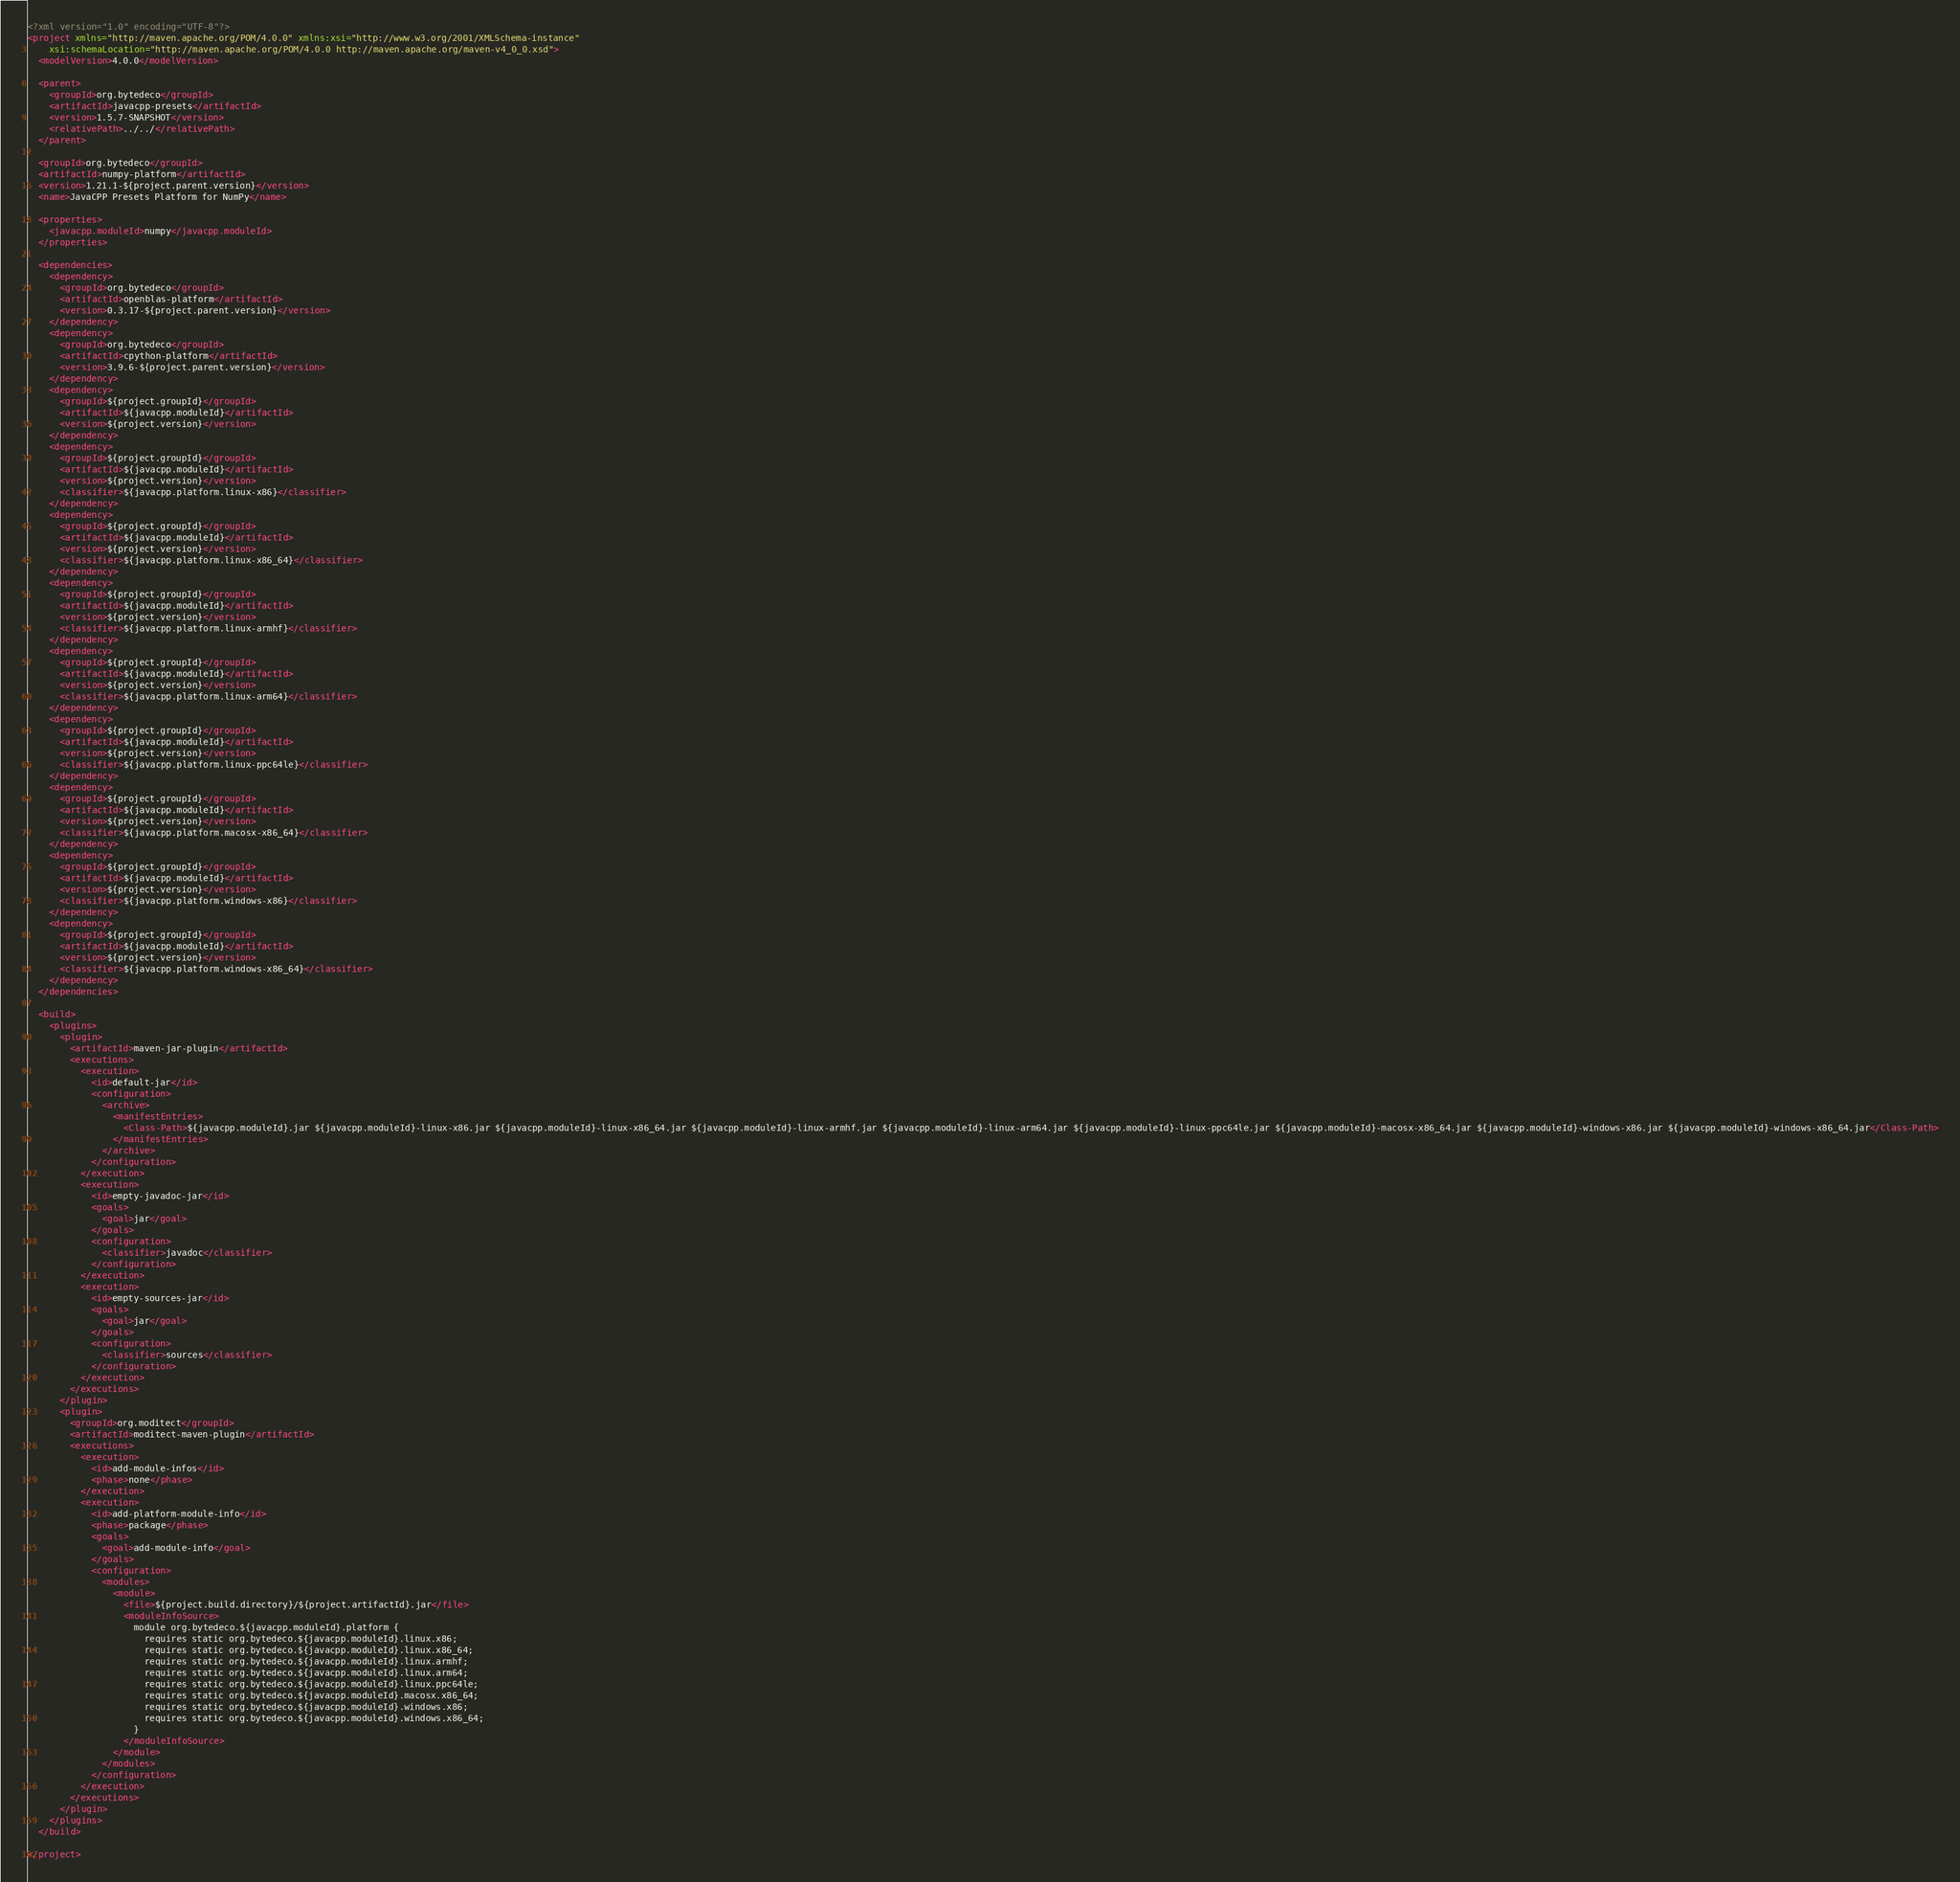Convert code to text. <code><loc_0><loc_0><loc_500><loc_500><_XML_><?xml version="1.0" encoding="UTF-8"?>
<project xmlns="http://maven.apache.org/POM/4.0.0" xmlns:xsi="http://www.w3.org/2001/XMLSchema-instance"
    xsi:schemaLocation="http://maven.apache.org/POM/4.0.0 http://maven.apache.org/maven-v4_0_0.xsd">
  <modelVersion>4.0.0</modelVersion>

  <parent>
    <groupId>org.bytedeco</groupId>
    <artifactId>javacpp-presets</artifactId>
    <version>1.5.7-SNAPSHOT</version>
    <relativePath>../../</relativePath>
  </parent>

  <groupId>org.bytedeco</groupId>
  <artifactId>numpy-platform</artifactId>
  <version>1.21.1-${project.parent.version}</version>
  <name>JavaCPP Presets Platform for NumPy</name>

  <properties>
    <javacpp.moduleId>numpy</javacpp.moduleId>
  </properties>

  <dependencies>
    <dependency>
      <groupId>org.bytedeco</groupId>
      <artifactId>openblas-platform</artifactId>
      <version>0.3.17-${project.parent.version}</version>
    </dependency>
    <dependency>
      <groupId>org.bytedeco</groupId>
      <artifactId>cpython-platform</artifactId>
      <version>3.9.6-${project.parent.version}</version>
    </dependency>
    <dependency>
      <groupId>${project.groupId}</groupId>
      <artifactId>${javacpp.moduleId}</artifactId>
      <version>${project.version}</version>
    </dependency>
    <dependency>
      <groupId>${project.groupId}</groupId>
      <artifactId>${javacpp.moduleId}</artifactId>
      <version>${project.version}</version>
      <classifier>${javacpp.platform.linux-x86}</classifier>
    </dependency>
    <dependency>
      <groupId>${project.groupId}</groupId>
      <artifactId>${javacpp.moduleId}</artifactId>
      <version>${project.version}</version>
      <classifier>${javacpp.platform.linux-x86_64}</classifier>
    </dependency>
    <dependency>
      <groupId>${project.groupId}</groupId>
      <artifactId>${javacpp.moduleId}</artifactId>
      <version>${project.version}</version>
      <classifier>${javacpp.platform.linux-armhf}</classifier>
    </dependency>
    <dependency>
      <groupId>${project.groupId}</groupId>
      <artifactId>${javacpp.moduleId}</artifactId>
      <version>${project.version}</version>
      <classifier>${javacpp.platform.linux-arm64}</classifier>
    </dependency>
    <dependency>
      <groupId>${project.groupId}</groupId>
      <artifactId>${javacpp.moduleId}</artifactId>
      <version>${project.version}</version>
      <classifier>${javacpp.platform.linux-ppc64le}</classifier>
    </dependency>
    <dependency>
      <groupId>${project.groupId}</groupId>
      <artifactId>${javacpp.moduleId}</artifactId>
      <version>${project.version}</version>
      <classifier>${javacpp.platform.macosx-x86_64}</classifier>
    </dependency>
    <dependency>
      <groupId>${project.groupId}</groupId>
      <artifactId>${javacpp.moduleId}</artifactId>
      <version>${project.version}</version>
      <classifier>${javacpp.platform.windows-x86}</classifier>
    </dependency>
    <dependency>
      <groupId>${project.groupId}</groupId>
      <artifactId>${javacpp.moduleId}</artifactId>
      <version>${project.version}</version>
      <classifier>${javacpp.platform.windows-x86_64}</classifier>
    </dependency>
  </dependencies>

  <build>
    <plugins>
      <plugin>
        <artifactId>maven-jar-plugin</artifactId>
        <executions>
          <execution>
            <id>default-jar</id>
            <configuration>
              <archive>
                <manifestEntries>
                  <Class-Path>${javacpp.moduleId}.jar ${javacpp.moduleId}-linux-x86.jar ${javacpp.moduleId}-linux-x86_64.jar ${javacpp.moduleId}-linux-armhf.jar ${javacpp.moduleId}-linux-arm64.jar ${javacpp.moduleId}-linux-ppc64le.jar ${javacpp.moduleId}-macosx-x86_64.jar ${javacpp.moduleId}-windows-x86.jar ${javacpp.moduleId}-windows-x86_64.jar</Class-Path>
                </manifestEntries>
              </archive>
            </configuration>
          </execution>
          <execution>
            <id>empty-javadoc-jar</id>
            <goals>
              <goal>jar</goal>
            </goals>
            <configuration>
              <classifier>javadoc</classifier>
            </configuration>
          </execution>
          <execution>
            <id>empty-sources-jar</id>
            <goals>
              <goal>jar</goal>
            </goals>
            <configuration>
              <classifier>sources</classifier>
            </configuration>
          </execution>
        </executions>
      </plugin>
      <plugin>
        <groupId>org.moditect</groupId>
        <artifactId>moditect-maven-plugin</artifactId>
        <executions>
          <execution>
            <id>add-module-infos</id>
            <phase>none</phase>
          </execution>
          <execution>
            <id>add-platform-module-info</id>
            <phase>package</phase>
            <goals>
              <goal>add-module-info</goal>
            </goals>
            <configuration>
              <modules>
                <module>
                  <file>${project.build.directory}/${project.artifactId}.jar</file>
                  <moduleInfoSource>
                    module org.bytedeco.${javacpp.moduleId}.platform {
                      requires static org.bytedeco.${javacpp.moduleId}.linux.x86;
                      requires static org.bytedeco.${javacpp.moduleId}.linux.x86_64;
                      requires static org.bytedeco.${javacpp.moduleId}.linux.armhf;
                      requires static org.bytedeco.${javacpp.moduleId}.linux.arm64;
                      requires static org.bytedeco.${javacpp.moduleId}.linux.ppc64le;
                      requires static org.bytedeco.${javacpp.moduleId}.macosx.x86_64;
                      requires static org.bytedeco.${javacpp.moduleId}.windows.x86;
                      requires static org.bytedeco.${javacpp.moduleId}.windows.x86_64;
                    }
                  </moduleInfoSource>
                </module>
              </modules>
            </configuration>
          </execution>
        </executions>
      </plugin>
    </plugins>
  </build>

</project>
</code> 